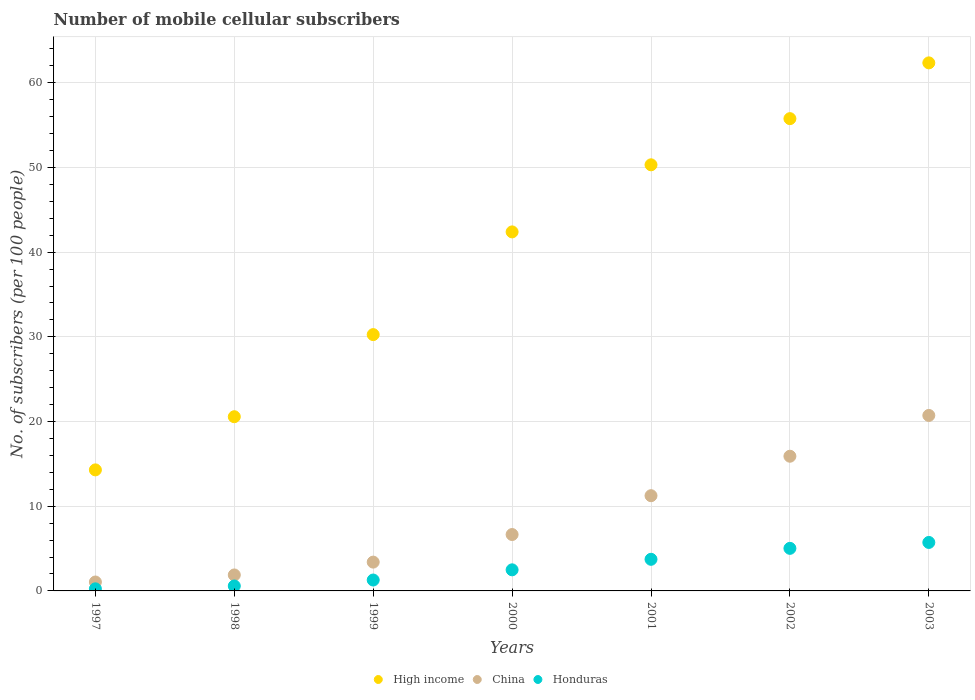How many different coloured dotlines are there?
Your answer should be compact. 3. Is the number of dotlines equal to the number of legend labels?
Offer a terse response. Yes. What is the number of mobile cellular subscribers in Honduras in 2003?
Provide a succinct answer. 5.72. Across all years, what is the maximum number of mobile cellular subscribers in Honduras?
Provide a short and direct response. 5.72. Across all years, what is the minimum number of mobile cellular subscribers in China?
Your answer should be compact. 1.05. In which year was the number of mobile cellular subscribers in Honduras maximum?
Make the answer very short. 2003. What is the total number of mobile cellular subscribers in High income in the graph?
Offer a very short reply. 275.95. What is the difference between the number of mobile cellular subscribers in China in 2001 and that in 2003?
Make the answer very short. -9.48. What is the difference between the number of mobile cellular subscribers in High income in 1998 and the number of mobile cellular subscribers in China in 2003?
Give a very brief answer. -0.15. What is the average number of mobile cellular subscribers in China per year?
Ensure brevity in your answer.  8.7. In the year 1999, what is the difference between the number of mobile cellular subscribers in China and number of mobile cellular subscribers in Honduras?
Provide a short and direct response. 2.11. In how many years, is the number of mobile cellular subscribers in High income greater than 18?
Offer a very short reply. 6. What is the ratio of the number of mobile cellular subscribers in High income in 1998 to that in 2003?
Your answer should be very brief. 0.33. Is the number of mobile cellular subscribers in Honduras in 1998 less than that in 2003?
Your response must be concise. Yes. Is the difference between the number of mobile cellular subscribers in China in 1997 and 2001 greater than the difference between the number of mobile cellular subscribers in Honduras in 1997 and 2001?
Give a very brief answer. No. What is the difference between the highest and the second highest number of mobile cellular subscribers in High income?
Your answer should be compact. 6.59. What is the difference between the highest and the lowest number of mobile cellular subscribers in China?
Your answer should be compact. 19.67. Is the sum of the number of mobile cellular subscribers in China in 1999 and 2002 greater than the maximum number of mobile cellular subscribers in High income across all years?
Provide a succinct answer. No. Does the number of mobile cellular subscribers in China monotonically increase over the years?
Provide a short and direct response. Yes. What is the difference between two consecutive major ticks on the Y-axis?
Give a very brief answer. 10. Are the values on the major ticks of Y-axis written in scientific E-notation?
Provide a short and direct response. No. Does the graph contain any zero values?
Provide a succinct answer. No. Does the graph contain grids?
Make the answer very short. Yes. Where does the legend appear in the graph?
Provide a short and direct response. Bottom center. How many legend labels are there?
Keep it short and to the point. 3. What is the title of the graph?
Your answer should be very brief. Number of mobile cellular subscribers. Does "Monaco" appear as one of the legend labels in the graph?
Your response must be concise. No. What is the label or title of the X-axis?
Offer a terse response. Years. What is the label or title of the Y-axis?
Provide a succinct answer. No. of subscribers (per 100 people). What is the No. of subscribers (per 100 people) of High income in 1997?
Make the answer very short. 14.29. What is the No. of subscribers (per 100 people) in China in 1997?
Your response must be concise. 1.05. What is the No. of subscribers (per 100 people) in Honduras in 1997?
Provide a succinct answer. 0.25. What is the No. of subscribers (per 100 people) in High income in 1998?
Provide a succinct answer. 20.57. What is the No. of subscribers (per 100 people) of China in 1998?
Your answer should be very brief. 1.89. What is the No. of subscribers (per 100 people) in Honduras in 1998?
Offer a very short reply. 0.58. What is the No. of subscribers (per 100 people) in High income in 1999?
Make the answer very short. 30.27. What is the No. of subscribers (per 100 people) in China in 1999?
Provide a short and direct response. 3.4. What is the No. of subscribers (per 100 people) of Honduras in 1999?
Offer a very short reply. 1.29. What is the No. of subscribers (per 100 people) in High income in 2000?
Give a very brief answer. 42.39. What is the No. of subscribers (per 100 people) of China in 2000?
Your response must be concise. 6.66. What is the No. of subscribers (per 100 people) in Honduras in 2000?
Make the answer very short. 2.49. What is the No. of subscribers (per 100 people) of High income in 2001?
Your answer should be very brief. 50.31. What is the No. of subscribers (per 100 people) in China in 2001?
Provide a short and direct response. 11.24. What is the No. of subscribers (per 100 people) of Honduras in 2001?
Your answer should be very brief. 3.73. What is the No. of subscribers (per 100 people) of High income in 2002?
Make the answer very short. 55.77. What is the No. of subscribers (per 100 people) in China in 2002?
Ensure brevity in your answer.  15.9. What is the No. of subscribers (per 100 people) in Honduras in 2002?
Offer a very short reply. 5.03. What is the No. of subscribers (per 100 people) of High income in 2003?
Your response must be concise. 62.35. What is the No. of subscribers (per 100 people) of China in 2003?
Your response must be concise. 20.72. What is the No. of subscribers (per 100 people) in Honduras in 2003?
Offer a terse response. 5.72. Across all years, what is the maximum No. of subscribers (per 100 people) in High income?
Keep it short and to the point. 62.35. Across all years, what is the maximum No. of subscribers (per 100 people) in China?
Provide a succinct answer. 20.72. Across all years, what is the maximum No. of subscribers (per 100 people) of Honduras?
Your answer should be very brief. 5.72. Across all years, what is the minimum No. of subscribers (per 100 people) of High income?
Make the answer very short. 14.29. Across all years, what is the minimum No. of subscribers (per 100 people) in China?
Your answer should be very brief. 1.05. Across all years, what is the minimum No. of subscribers (per 100 people) of Honduras?
Ensure brevity in your answer.  0.25. What is the total No. of subscribers (per 100 people) of High income in the graph?
Offer a terse response. 275.95. What is the total No. of subscribers (per 100 people) of China in the graph?
Give a very brief answer. 60.87. What is the total No. of subscribers (per 100 people) in Honduras in the graph?
Ensure brevity in your answer.  19.09. What is the difference between the No. of subscribers (per 100 people) in High income in 1997 and that in 1998?
Provide a succinct answer. -6.28. What is the difference between the No. of subscribers (per 100 people) of Honduras in 1997 and that in 1998?
Provide a short and direct response. -0.34. What is the difference between the No. of subscribers (per 100 people) in High income in 1997 and that in 1999?
Your answer should be compact. -15.97. What is the difference between the No. of subscribers (per 100 people) in China in 1997 and that in 1999?
Your response must be concise. -2.35. What is the difference between the No. of subscribers (per 100 people) of Honduras in 1997 and that in 1999?
Offer a terse response. -1.04. What is the difference between the No. of subscribers (per 100 people) of High income in 1997 and that in 2000?
Provide a succinct answer. -28.1. What is the difference between the No. of subscribers (per 100 people) in China in 1997 and that in 2000?
Your answer should be very brief. -5.61. What is the difference between the No. of subscribers (per 100 people) in Honduras in 1997 and that in 2000?
Give a very brief answer. -2.24. What is the difference between the No. of subscribers (per 100 people) of High income in 1997 and that in 2001?
Your answer should be very brief. -36.02. What is the difference between the No. of subscribers (per 100 people) of China in 1997 and that in 2001?
Provide a succinct answer. -10.19. What is the difference between the No. of subscribers (per 100 people) in Honduras in 1997 and that in 2001?
Your response must be concise. -3.49. What is the difference between the No. of subscribers (per 100 people) in High income in 1997 and that in 2002?
Provide a succinct answer. -41.47. What is the difference between the No. of subscribers (per 100 people) in China in 1997 and that in 2002?
Offer a terse response. -14.85. What is the difference between the No. of subscribers (per 100 people) in Honduras in 1997 and that in 2002?
Give a very brief answer. -4.78. What is the difference between the No. of subscribers (per 100 people) in High income in 1997 and that in 2003?
Your response must be concise. -48.06. What is the difference between the No. of subscribers (per 100 people) of China in 1997 and that in 2003?
Your response must be concise. -19.67. What is the difference between the No. of subscribers (per 100 people) of Honduras in 1997 and that in 2003?
Keep it short and to the point. -5.48. What is the difference between the No. of subscribers (per 100 people) in High income in 1998 and that in 1999?
Offer a very short reply. -9.7. What is the difference between the No. of subscribers (per 100 people) in China in 1998 and that in 1999?
Make the answer very short. -1.52. What is the difference between the No. of subscribers (per 100 people) of Honduras in 1998 and that in 1999?
Provide a short and direct response. -0.7. What is the difference between the No. of subscribers (per 100 people) of High income in 1998 and that in 2000?
Offer a terse response. -21.82. What is the difference between the No. of subscribers (per 100 people) of China in 1998 and that in 2000?
Keep it short and to the point. -4.77. What is the difference between the No. of subscribers (per 100 people) in Honduras in 1998 and that in 2000?
Keep it short and to the point. -1.91. What is the difference between the No. of subscribers (per 100 people) of High income in 1998 and that in 2001?
Make the answer very short. -29.74. What is the difference between the No. of subscribers (per 100 people) of China in 1998 and that in 2001?
Keep it short and to the point. -9.36. What is the difference between the No. of subscribers (per 100 people) in Honduras in 1998 and that in 2001?
Ensure brevity in your answer.  -3.15. What is the difference between the No. of subscribers (per 100 people) in High income in 1998 and that in 2002?
Give a very brief answer. -35.2. What is the difference between the No. of subscribers (per 100 people) in China in 1998 and that in 2002?
Make the answer very short. -14.02. What is the difference between the No. of subscribers (per 100 people) of Honduras in 1998 and that in 2002?
Your answer should be compact. -4.44. What is the difference between the No. of subscribers (per 100 people) in High income in 1998 and that in 2003?
Your answer should be very brief. -41.78. What is the difference between the No. of subscribers (per 100 people) of China in 1998 and that in 2003?
Keep it short and to the point. -18.83. What is the difference between the No. of subscribers (per 100 people) of Honduras in 1998 and that in 2003?
Keep it short and to the point. -5.14. What is the difference between the No. of subscribers (per 100 people) in High income in 1999 and that in 2000?
Offer a terse response. -12.13. What is the difference between the No. of subscribers (per 100 people) of China in 1999 and that in 2000?
Your answer should be compact. -3.26. What is the difference between the No. of subscribers (per 100 people) in Honduras in 1999 and that in 2000?
Ensure brevity in your answer.  -1.2. What is the difference between the No. of subscribers (per 100 people) in High income in 1999 and that in 2001?
Keep it short and to the point. -20.05. What is the difference between the No. of subscribers (per 100 people) in China in 1999 and that in 2001?
Your response must be concise. -7.84. What is the difference between the No. of subscribers (per 100 people) of Honduras in 1999 and that in 2001?
Your response must be concise. -2.45. What is the difference between the No. of subscribers (per 100 people) of High income in 1999 and that in 2002?
Give a very brief answer. -25.5. What is the difference between the No. of subscribers (per 100 people) of China in 1999 and that in 2002?
Your answer should be very brief. -12.5. What is the difference between the No. of subscribers (per 100 people) of Honduras in 1999 and that in 2002?
Offer a terse response. -3.74. What is the difference between the No. of subscribers (per 100 people) in High income in 1999 and that in 2003?
Provide a short and direct response. -32.09. What is the difference between the No. of subscribers (per 100 people) in China in 1999 and that in 2003?
Provide a short and direct response. -17.32. What is the difference between the No. of subscribers (per 100 people) of Honduras in 1999 and that in 2003?
Provide a succinct answer. -4.44. What is the difference between the No. of subscribers (per 100 people) in High income in 2000 and that in 2001?
Your answer should be compact. -7.92. What is the difference between the No. of subscribers (per 100 people) of China in 2000 and that in 2001?
Ensure brevity in your answer.  -4.59. What is the difference between the No. of subscribers (per 100 people) of Honduras in 2000 and that in 2001?
Your answer should be very brief. -1.24. What is the difference between the No. of subscribers (per 100 people) of High income in 2000 and that in 2002?
Your response must be concise. -13.37. What is the difference between the No. of subscribers (per 100 people) in China in 2000 and that in 2002?
Give a very brief answer. -9.25. What is the difference between the No. of subscribers (per 100 people) of Honduras in 2000 and that in 2002?
Ensure brevity in your answer.  -2.54. What is the difference between the No. of subscribers (per 100 people) of High income in 2000 and that in 2003?
Provide a succinct answer. -19.96. What is the difference between the No. of subscribers (per 100 people) of China in 2000 and that in 2003?
Ensure brevity in your answer.  -14.06. What is the difference between the No. of subscribers (per 100 people) in Honduras in 2000 and that in 2003?
Your answer should be compact. -3.23. What is the difference between the No. of subscribers (per 100 people) in High income in 2001 and that in 2002?
Keep it short and to the point. -5.45. What is the difference between the No. of subscribers (per 100 people) of China in 2001 and that in 2002?
Your answer should be very brief. -4.66. What is the difference between the No. of subscribers (per 100 people) of Honduras in 2001 and that in 2002?
Give a very brief answer. -1.29. What is the difference between the No. of subscribers (per 100 people) in High income in 2001 and that in 2003?
Offer a terse response. -12.04. What is the difference between the No. of subscribers (per 100 people) in China in 2001 and that in 2003?
Provide a succinct answer. -9.48. What is the difference between the No. of subscribers (per 100 people) in Honduras in 2001 and that in 2003?
Offer a terse response. -1.99. What is the difference between the No. of subscribers (per 100 people) of High income in 2002 and that in 2003?
Keep it short and to the point. -6.59. What is the difference between the No. of subscribers (per 100 people) of China in 2002 and that in 2003?
Your response must be concise. -4.82. What is the difference between the No. of subscribers (per 100 people) of Honduras in 2002 and that in 2003?
Keep it short and to the point. -0.7. What is the difference between the No. of subscribers (per 100 people) in High income in 1997 and the No. of subscribers (per 100 people) in China in 1998?
Keep it short and to the point. 12.41. What is the difference between the No. of subscribers (per 100 people) in High income in 1997 and the No. of subscribers (per 100 people) in Honduras in 1998?
Provide a short and direct response. 13.71. What is the difference between the No. of subscribers (per 100 people) of China in 1997 and the No. of subscribers (per 100 people) of Honduras in 1998?
Your response must be concise. 0.47. What is the difference between the No. of subscribers (per 100 people) in High income in 1997 and the No. of subscribers (per 100 people) in China in 1999?
Give a very brief answer. 10.89. What is the difference between the No. of subscribers (per 100 people) of High income in 1997 and the No. of subscribers (per 100 people) of Honduras in 1999?
Your answer should be compact. 13.01. What is the difference between the No. of subscribers (per 100 people) in China in 1997 and the No. of subscribers (per 100 people) in Honduras in 1999?
Provide a short and direct response. -0.23. What is the difference between the No. of subscribers (per 100 people) in High income in 1997 and the No. of subscribers (per 100 people) in China in 2000?
Give a very brief answer. 7.63. What is the difference between the No. of subscribers (per 100 people) of High income in 1997 and the No. of subscribers (per 100 people) of Honduras in 2000?
Keep it short and to the point. 11.8. What is the difference between the No. of subscribers (per 100 people) of China in 1997 and the No. of subscribers (per 100 people) of Honduras in 2000?
Make the answer very short. -1.44. What is the difference between the No. of subscribers (per 100 people) in High income in 1997 and the No. of subscribers (per 100 people) in China in 2001?
Provide a short and direct response. 3.05. What is the difference between the No. of subscribers (per 100 people) of High income in 1997 and the No. of subscribers (per 100 people) of Honduras in 2001?
Your answer should be very brief. 10.56. What is the difference between the No. of subscribers (per 100 people) of China in 1997 and the No. of subscribers (per 100 people) of Honduras in 2001?
Make the answer very short. -2.68. What is the difference between the No. of subscribers (per 100 people) of High income in 1997 and the No. of subscribers (per 100 people) of China in 2002?
Ensure brevity in your answer.  -1.61. What is the difference between the No. of subscribers (per 100 people) in High income in 1997 and the No. of subscribers (per 100 people) in Honduras in 2002?
Your response must be concise. 9.27. What is the difference between the No. of subscribers (per 100 people) of China in 1997 and the No. of subscribers (per 100 people) of Honduras in 2002?
Offer a very short reply. -3.97. What is the difference between the No. of subscribers (per 100 people) in High income in 1997 and the No. of subscribers (per 100 people) in China in 2003?
Give a very brief answer. -6.43. What is the difference between the No. of subscribers (per 100 people) in High income in 1997 and the No. of subscribers (per 100 people) in Honduras in 2003?
Provide a succinct answer. 8.57. What is the difference between the No. of subscribers (per 100 people) in China in 1997 and the No. of subscribers (per 100 people) in Honduras in 2003?
Offer a very short reply. -4.67. What is the difference between the No. of subscribers (per 100 people) of High income in 1998 and the No. of subscribers (per 100 people) of China in 1999?
Make the answer very short. 17.17. What is the difference between the No. of subscribers (per 100 people) in High income in 1998 and the No. of subscribers (per 100 people) in Honduras in 1999?
Offer a terse response. 19.28. What is the difference between the No. of subscribers (per 100 people) of China in 1998 and the No. of subscribers (per 100 people) of Honduras in 1999?
Provide a short and direct response. 0.6. What is the difference between the No. of subscribers (per 100 people) of High income in 1998 and the No. of subscribers (per 100 people) of China in 2000?
Offer a very short reply. 13.91. What is the difference between the No. of subscribers (per 100 people) in High income in 1998 and the No. of subscribers (per 100 people) in Honduras in 2000?
Your response must be concise. 18.08. What is the difference between the No. of subscribers (per 100 people) in China in 1998 and the No. of subscribers (per 100 people) in Honduras in 2000?
Your answer should be compact. -0.6. What is the difference between the No. of subscribers (per 100 people) in High income in 1998 and the No. of subscribers (per 100 people) in China in 2001?
Give a very brief answer. 9.33. What is the difference between the No. of subscribers (per 100 people) of High income in 1998 and the No. of subscribers (per 100 people) of Honduras in 2001?
Keep it short and to the point. 16.84. What is the difference between the No. of subscribers (per 100 people) in China in 1998 and the No. of subscribers (per 100 people) in Honduras in 2001?
Give a very brief answer. -1.85. What is the difference between the No. of subscribers (per 100 people) in High income in 1998 and the No. of subscribers (per 100 people) in China in 2002?
Make the answer very short. 4.67. What is the difference between the No. of subscribers (per 100 people) of High income in 1998 and the No. of subscribers (per 100 people) of Honduras in 2002?
Provide a short and direct response. 15.54. What is the difference between the No. of subscribers (per 100 people) of China in 1998 and the No. of subscribers (per 100 people) of Honduras in 2002?
Your response must be concise. -3.14. What is the difference between the No. of subscribers (per 100 people) in High income in 1998 and the No. of subscribers (per 100 people) in China in 2003?
Offer a very short reply. -0.15. What is the difference between the No. of subscribers (per 100 people) of High income in 1998 and the No. of subscribers (per 100 people) of Honduras in 2003?
Offer a terse response. 14.85. What is the difference between the No. of subscribers (per 100 people) of China in 1998 and the No. of subscribers (per 100 people) of Honduras in 2003?
Your answer should be compact. -3.84. What is the difference between the No. of subscribers (per 100 people) of High income in 1999 and the No. of subscribers (per 100 people) of China in 2000?
Your answer should be very brief. 23.61. What is the difference between the No. of subscribers (per 100 people) of High income in 1999 and the No. of subscribers (per 100 people) of Honduras in 2000?
Your response must be concise. 27.78. What is the difference between the No. of subscribers (per 100 people) of China in 1999 and the No. of subscribers (per 100 people) of Honduras in 2000?
Provide a short and direct response. 0.91. What is the difference between the No. of subscribers (per 100 people) in High income in 1999 and the No. of subscribers (per 100 people) in China in 2001?
Your answer should be compact. 19.02. What is the difference between the No. of subscribers (per 100 people) of High income in 1999 and the No. of subscribers (per 100 people) of Honduras in 2001?
Your response must be concise. 26.53. What is the difference between the No. of subscribers (per 100 people) of China in 1999 and the No. of subscribers (per 100 people) of Honduras in 2001?
Your answer should be very brief. -0.33. What is the difference between the No. of subscribers (per 100 people) of High income in 1999 and the No. of subscribers (per 100 people) of China in 2002?
Offer a very short reply. 14.36. What is the difference between the No. of subscribers (per 100 people) of High income in 1999 and the No. of subscribers (per 100 people) of Honduras in 2002?
Give a very brief answer. 25.24. What is the difference between the No. of subscribers (per 100 people) of China in 1999 and the No. of subscribers (per 100 people) of Honduras in 2002?
Offer a very short reply. -1.63. What is the difference between the No. of subscribers (per 100 people) in High income in 1999 and the No. of subscribers (per 100 people) in China in 2003?
Offer a very short reply. 9.54. What is the difference between the No. of subscribers (per 100 people) of High income in 1999 and the No. of subscribers (per 100 people) of Honduras in 2003?
Your response must be concise. 24.54. What is the difference between the No. of subscribers (per 100 people) of China in 1999 and the No. of subscribers (per 100 people) of Honduras in 2003?
Keep it short and to the point. -2.32. What is the difference between the No. of subscribers (per 100 people) in High income in 2000 and the No. of subscribers (per 100 people) in China in 2001?
Ensure brevity in your answer.  31.15. What is the difference between the No. of subscribers (per 100 people) in High income in 2000 and the No. of subscribers (per 100 people) in Honduras in 2001?
Keep it short and to the point. 38.66. What is the difference between the No. of subscribers (per 100 people) in China in 2000 and the No. of subscribers (per 100 people) in Honduras in 2001?
Your answer should be very brief. 2.93. What is the difference between the No. of subscribers (per 100 people) in High income in 2000 and the No. of subscribers (per 100 people) in China in 2002?
Provide a succinct answer. 26.49. What is the difference between the No. of subscribers (per 100 people) of High income in 2000 and the No. of subscribers (per 100 people) of Honduras in 2002?
Give a very brief answer. 37.37. What is the difference between the No. of subscribers (per 100 people) of China in 2000 and the No. of subscribers (per 100 people) of Honduras in 2002?
Your response must be concise. 1.63. What is the difference between the No. of subscribers (per 100 people) in High income in 2000 and the No. of subscribers (per 100 people) in China in 2003?
Your answer should be very brief. 21.67. What is the difference between the No. of subscribers (per 100 people) in High income in 2000 and the No. of subscribers (per 100 people) in Honduras in 2003?
Offer a very short reply. 36.67. What is the difference between the No. of subscribers (per 100 people) of China in 2000 and the No. of subscribers (per 100 people) of Honduras in 2003?
Provide a short and direct response. 0.94. What is the difference between the No. of subscribers (per 100 people) of High income in 2001 and the No. of subscribers (per 100 people) of China in 2002?
Give a very brief answer. 34.41. What is the difference between the No. of subscribers (per 100 people) in High income in 2001 and the No. of subscribers (per 100 people) in Honduras in 2002?
Offer a terse response. 45.29. What is the difference between the No. of subscribers (per 100 people) in China in 2001 and the No. of subscribers (per 100 people) in Honduras in 2002?
Ensure brevity in your answer.  6.22. What is the difference between the No. of subscribers (per 100 people) in High income in 2001 and the No. of subscribers (per 100 people) in China in 2003?
Ensure brevity in your answer.  29.59. What is the difference between the No. of subscribers (per 100 people) of High income in 2001 and the No. of subscribers (per 100 people) of Honduras in 2003?
Make the answer very short. 44.59. What is the difference between the No. of subscribers (per 100 people) of China in 2001 and the No. of subscribers (per 100 people) of Honduras in 2003?
Your answer should be very brief. 5.52. What is the difference between the No. of subscribers (per 100 people) in High income in 2002 and the No. of subscribers (per 100 people) in China in 2003?
Make the answer very short. 35.05. What is the difference between the No. of subscribers (per 100 people) of High income in 2002 and the No. of subscribers (per 100 people) of Honduras in 2003?
Keep it short and to the point. 50.04. What is the difference between the No. of subscribers (per 100 people) in China in 2002 and the No. of subscribers (per 100 people) in Honduras in 2003?
Your answer should be very brief. 10.18. What is the average No. of subscribers (per 100 people) of High income per year?
Your answer should be very brief. 39.42. What is the average No. of subscribers (per 100 people) in China per year?
Keep it short and to the point. 8.7. What is the average No. of subscribers (per 100 people) in Honduras per year?
Your response must be concise. 2.73. In the year 1997, what is the difference between the No. of subscribers (per 100 people) of High income and No. of subscribers (per 100 people) of China?
Give a very brief answer. 13.24. In the year 1997, what is the difference between the No. of subscribers (per 100 people) in High income and No. of subscribers (per 100 people) in Honduras?
Your response must be concise. 14.05. In the year 1997, what is the difference between the No. of subscribers (per 100 people) in China and No. of subscribers (per 100 people) in Honduras?
Ensure brevity in your answer.  0.81. In the year 1998, what is the difference between the No. of subscribers (per 100 people) in High income and No. of subscribers (per 100 people) in China?
Your answer should be very brief. 18.68. In the year 1998, what is the difference between the No. of subscribers (per 100 people) in High income and No. of subscribers (per 100 people) in Honduras?
Ensure brevity in your answer.  19.99. In the year 1998, what is the difference between the No. of subscribers (per 100 people) of China and No. of subscribers (per 100 people) of Honduras?
Provide a short and direct response. 1.3. In the year 1999, what is the difference between the No. of subscribers (per 100 people) in High income and No. of subscribers (per 100 people) in China?
Your response must be concise. 26.86. In the year 1999, what is the difference between the No. of subscribers (per 100 people) in High income and No. of subscribers (per 100 people) in Honduras?
Your answer should be compact. 28.98. In the year 1999, what is the difference between the No. of subscribers (per 100 people) of China and No. of subscribers (per 100 people) of Honduras?
Provide a succinct answer. 2.11. In the year 2000, what is the difference between the No. of subscribers (per 100 people) of High income and No. of subscribers (per 100 people) of China?
Your answer should be compact. 35.73. In the year 2000, what is the difference between the No. of subscribers (per 100 people) of High income and No. of subscribers (per 100 people) of Honduras?
Offer a terse response. 39.9. In the year 2000, what is the difference between the No. of subscribers (per 100 people) in China and No. of subscribers (per 100 people) in Honduras?
Provide a succinct answer. 4.17. In the year 2001, what is the difference between the No. of subscribers (per 100 people) of High income and No. of subscribers (per 100 people) of China?
Make the answer very short. 39.07. In the year 2001, what is the difference between the No. of subscribers (per 100 people) in High income and No. of subscribers (per 100 people) in Honduras?
Offer a very short reply. 46.58. In the year 2001, what is the difference between the No. of subscribers (per 100 people) of China and No. of subscribers (per 100 people) of Honduras?
Ensure brevity in your answer.  7.51. In the year 2002, what is the difference between the No. of subscribers (per 100 people) in High income and No. of subscribers (per 100 people) in China?
Your response must be concise. 39.86. In the year 2002, what is the difference between the No. of subscribers (per 100 people) in High income and No. of subscribers (per 100 people) in Honduras?
Your answer should be very brief. 50.74. In the year 2002, what is the difference between the No. of subscribers (per 100 people) of China and No. of subscribers (per 100 people) of Honduras?
Provide a succinct answer. 10.88. In the year 2003, what is the difference between the No. of subscribers (per 100 people) of High income and No. of subscribers (per 100 people) of China?
Provide a short and direct response. 41.63. In the year 2003, what is the difference between the No. of subscribers (per 100 people) of High income and No. of subscribers (per 100 people) of Honduras?
Keep it short and to the point. 56.63. In the year 2003, what is the difference between the No. of subscribers (per 100 people) in China and No. of subscribers (per 100 people) in Honduras?
Offer a very short reply. 15. What is the ratio of the No. of subscribers (per 100 people) of High income in 1997 to that in 1998?
Ensure brevity in your answer.  0.69. What is the ratio of the No. of subscribers (per 100 people) of China in 1997 to that in 1998?
Give a very brief answer. 0.56. What is the ratio of the No. of subscribers (per 100 people) of Honduras in 1997 to that in 1998?
Make the answer very short. 0.42. What is the ratio of the No. of subscribers (per 100 people) of High income in 1997 to that in 1999?
Offer a very short reply. 0.47. What is the ratio of the No. of subscribers (per 100 people) of China in 1997 to that in 1999?
Your answer should be compact. 0.31. What is the ratio of the No. of subscribers (per 100 people) of Honduras in 1997 to that in 1999?
Provide a short and direct response. 0.19. What is the ratio of the No. of subscribers (per 100 people) in High income in 1997 to that in 2000?
Offer a very short reply. 0.34. What is the ratio of the No. of subscribers (per 100 people) of China in 1997 to that in 2000?
Ensure brevity in your answer.  0.16. What is the ratio of the No. of subscribers (per 100 people) in Honduras in 1997 to that in 2000?
Your answer should be very brief. 0.1. What is the ratio of the No. of subscribers (per 100 people) in High income in 1997 to that in 2001?
Your response must be concise. 0.28. What is the ratio of the No. of subscribers (per 100 people) in China in 1997 to that in 2001?
Offer a terse response. 0.09. What is the ratio of the No. of subscribers (per 100 people) in Honduras in 1997 to that in 2001?
Provide a short and direct response. 0.07. What is the ratio of the No. of subscribers (per 100 people) in High income in 1997 to that in 2002?
Offer a very short reply. 0.26. What is the ratio of the No. of subscribers (per 100 people) of China in 1997 to that in 2002?
Offer a terse response. 0.07. What is the ratio of the No. of subscribers (per 100 people) in Honduras in 1997 to that in 2002?
Offer a very short reply. 0.05. What is the ratio of the No. of subscribers (per 100 people) in High income in 1997 to that in 2003?
Keep it short and to the point. 0.23. What is the ratio of the No. of subscribers (per 100 people) of China in 1997 to that in 2003?
Give a very brief answer. 0.05. What is the ratio of the No. of subscribers (per 100 people) in Honduras in 1997 to that in 2003?
Provide a succinct answer. 0.04. What is the ratio of the No. of subscribers (per 100 people) in High income in 1998 to that in 1999?
Your answer should be compact. 0.68. What is the ratio of the No. of subscribers (per 100 people) in China in 1998 to that in 1999?
Your response must be concise. 0.55. What is the ratio of the No. of subscribers (per 100 people) in Honduras in 1998 to that in 1999?
Offer a terse response. 0.45. What is the ratio of the No. of subscribers (per 100 people) in High income in 1998 to that in 2000?
Ensure brevity in your answer.  0.49. What is the ratio of the No. of subscribers (per 100 people) of China in 1998 to that in 2000?
Keep it short and to the point. 0.28. What is the ratio of the No. of subscribers (per 100 people) of Honduras in 1998 to that in 2000?
Your answer should be compact. 0.23. What is the ratio of the No. of subscribers (per 100 people) in High income in 1998 to that in 2001?
Make the answer very short. 0.41. What is the ratio of the No. of subscribers (per 100 people) of China in 1998 to that in 2001?
Keep it short and to the point. 0.17. What is the ratio of the No. of subscribers (per 100 people) in Honduras in 1998 to that in 2001?
Your answer should be compact. 0.16. What is the ratio of the No. of subscribers (per 100 people) of High income in 1998 to that in 2002?
Ensure brevity in your answer.  0.37. What is the ratio of the No. of subscribers (per 100 people) of China in 1998 to that in 2002?
Offer a very short reply. 0.12. What is the ratio of the No. of subscribers (per 100 people) of Honduras in 1998 to that in 2002?
Ensure brevity in your answer.  0.12. What is the ratio of the No. of subscribers (per 100 people) of High income in 1998 to that in 2003?
Your answer should be very brief. 0.33. What is the ratio of the No. of subscribers (per 100 people) in China in 1998 to that in 2003?
Your response must be concise. 0.09. What is the ratio of the No. of subscribers (per 100 people) in Honduras in 1998 to that in 2003?
Your answer should be compact. 0.1. What is the ratio of the No. of subscribers (per 100 people) of High income in 1999 to that in 2000?
Offer a terse response. 0.71. What is the ratio of the No. of subscribers (per 100 people) of China in 1999 to that in 2000?
Give a very brief answer. 0.51. What is the ratio of the No. of subscribers (per 100 people) of Honduras in 1999 to that in 2000?
Ensure brevity in your answer.  0.52. What is the ratio of the No. of subscribers (per 100 people) of High income in 1999 to that in 2001?
Your answer should be compact. 0.6. What is the ratio of the No. of subscribers (per 100 people) in China in 1999 to that in 2001?
Your response must be concise. 0.3. What is the ratio of the No. of subscribers (per 100 people) in Honduras in 1999 to that in 2001?
Offer a terse response. 0.34. What is the ratio of the No. of subscribers (per 100 people) of High income in 1999 to that in 2002?
Offer a very short reply. 0.54. What is the ratio of the No. of subscribers (per 100 people) of China in 1999 to that in 2002?
Provide a short and direct response. 0.21. What is the ratio of the No. of subscribers (per 100 people) of Honduras in 1999 to that in 2002?
Ensure brevity in your answer.  0.26. What is the ratio of the No. of subscribers (per 100 people) in High income in 1999 to that in 2003?
Your answer should be very brief. 0.49. What is the ratio of the No. of subscribers (per 100 people) of China in 1999 to that in 2003?
Provide a short and direct response. 0.16. What is the ratio of the No. of subscribers (per 100 people) of Honduras in 1999 to that in 2003?
Offer a terse response. 0.22. What is the ratio of the No. of subscribers (per 100 people) of High income in 2000 to that in 2001?
Provide a succinct answer. 0.84. What is the ratio of the No. of subscribers (per 100 people) in China in 2000 to that in 2001?
Provide a short and direct response. 0.59. What is the ratio of the No. of subscribers (per 100 people) of Honduras in 2000 to that in 2001?
Ensure brevity in your answer.  0.67. What is the ratio of the No. of subscribers (per 100 people) in High income in 2000 to that in 2002?
Your answer should be very brief. 0.76. What is the ratio of the No. of subscribers (per 100 people) of China in 2000 to that in 2002?
Your answer should be compact. 0.42. What is the ratio of the No. of subscribers (per 100 people) in Honduras in 2000 to that in 2002?
Keep it short and to the point. 0.5. What is the ratio of the No. of subscribers (per 100 people) in High income in 2000 to that in 2003?
Your answer should be very brief. 0.68. What is the ratio of the No. of subscribers (per 100 people) of China in 2000 to that in 2003?
Your answer should be very brief. 0.32. What is the ratio of the No. of subscribers (per 100 people) of Honduras in 2000 to that in 2003?
Offer a very short reply. 0.44. What is the ratio of the No. of subscribers (per 100 people) in High income in 2001 to that in 2002?
Make the answer very short. 0.9. What is the ratio of the No. of subscribers (per 100 people) in China in 2001 to that in 2002?
Ensure brevity in your answer.  0.71. What is the ratio of the No. of subscribers (per 100 people) in Honduras in 2001 to that in 2002?
Keep it short and to the point. 0.74. What is the ratio of the No. of subscribers (per 100 people) of High income in 2001 to that in 2003?
Provide a succinct answer. 0.81. What is the ratio of the No. of subscribers (per 100 people) of China in 2001 to that in 2003?
Ensure brevity in your answer.  0.54. What is the ratio of the No. of subscribers (per 100 people) of Honduras in 2001 to that in 2003?
Provide a succinct answer. 0.65. What is the ratio of the No. of subscribers (per 100 people) of High income in 2002 to that in 2003?
Offer a very short reply. 0.89. What is the ratio of the No. of subscribers (per 100 people) in China in 2002 to that in 2003?
Your response must be concise. 0.77. What is the ratio of the No. of subscribers (per 100 people) in Honduras in 2002 to that in 2003?
Keep it short and to the point. 0.88. What is the difference between the highest and the second highest No. of subscribers (per 100 people) of High income?
Provide a succinct answer. 6.59. What is the difference between the highest and the second highest No. of subscribers (per 100 people) in China?
Your answer should be compact. 4.82. What is the difference between the highest and the second highest No. of subscribers (per 100 people) of Honduras?
Offer a terse response. 0.7. What is the difference between the highest and the lowest No. of subscribers (per 100 people) in High income?
Make the answer very short. 48.06. What is the difference between the highest and the lowest No. of subscribers (per 100 people) of China?
Provide a short and direct response. 19.67. What is the difference between the highest and the lowest No. of subscribers (per 100 people) of Honduras?
Your answer should be very brief. 5.48. 